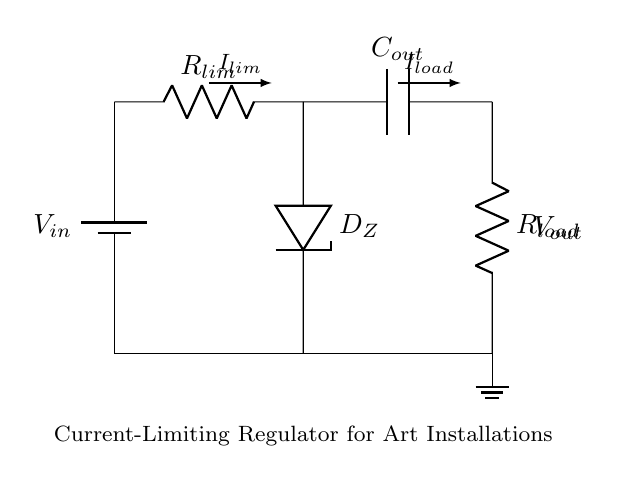What is the input voltage of this circuit? The input voltage is labeled as V_in, which is connected to the top of the current limiting resistor and is supplied by the battery.
Answer: V_in What component is used for current limiting? The component used for current limiting is labeled R_lim, which is a resistor placed in series with the input.
Answer: R_lim Which component regulates the voltage? The component that regulates the voltage is a Zener diode labeled D_Z, which is connected to ground and stabilizes the output voltage.
Answer: D_Z What is the role of the capacitor in this circuit? The capacitor, labeled C_out, is used to smooth out the voltage at the output, providing stability and reducing noise in the circuit.
Answer: Smoothing What current flows through the load? The current flowing through the load is labeled as I_load, which exits the output capacitor and passes through the load resistor.
Answer: I_load How is the output voltage marked? The output voltage is marked as V_out, which is the voltage measured across the load resistor R_load.
Answer: V_out What is the purpose of the ground connection? The ground connection provides a common return path for the electric current and establishes the reference point for the voltage measurements in the circuit.
Answer: Common return 